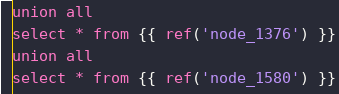Convert code to text. <code><loc_0><loc_0><loc_500><loc_500><_SQL_>union all
select * from {{ ref('node_1376') }}
union all
select * from {{ ref('node_1580') }}
</code> 